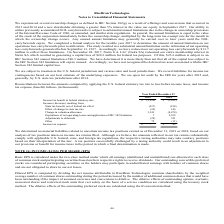From Ricebran Technologies's financial document, What are the respective income tax benefits in 2018 and 2019? The document shows two values: 1,692 and 2,928 (in thousands). From the document: "Income tax benefit at federal statutory rate (2,928) $ (1,692) $ tax benefit at federal statutory rate (2,928) $ (1,692) $..." Also, What are the respective state tax benefit, net of federal tax effect in 2018 and 2019? The document shows two values: 184 and 437 (in thousands). From the document: "ate tax benefit, net of federal tax effect (437) (184) om: State tax benefit, net of federal tax effect (437) (184)..." Also, What are the respective expirations of net operating losses and application of IRC 382 limitation in 2018 and 2019? The document shows two values: 9,939 and 7 (in thousands). From the document: "ting losses and application of IRC 382 limitation 7 9,939 ng losses and application of IRC 382 limitation 7 9,939..." Also, can you calculate: What is the average income tax benefit in 2018 and 2019? To answer this question, I need to perform calculations using the financial data. The calculation is: (1,692 + 2,928)/2 , which equals 2310 (in thousands). This is based on the information: "Income tax benefit at federal statutory rate (2,928) $ (1,692) $ tax benefit at federal statutory rate (2,928) $ (1,692) $..." The key data points involved are: 1,692, 2,928. Also, can you calculate: What is the change in income tax benefit between 2018 and 2019? Based on the calculation: 2,928 - 1,692 , the result is 1236 (in thousands). This is based on the information: "Income tax benefit at federal statutory rate (2,928) $ (1,692) $ tax benefit at federal statutory rate (2,928) $ (1,692) $..." The key data points involved are: 1,692, 2,928. Also, can you calculate: What is the percentage change in the income tax benefit between 2018 and 2019? To answer this question, I need to perform calculations using the financial data. The calculation is: (2,928 - 1,692)/1,692 , which equals 73.05 (percentage). This is based on the information: "Income tax benefit at federal statutory rate (2,928) $ (1,692) $ tax benefit at federal statutory rate (2,928) $ (1,692) $..." The key data points involved are: 1,692, 2,928. 